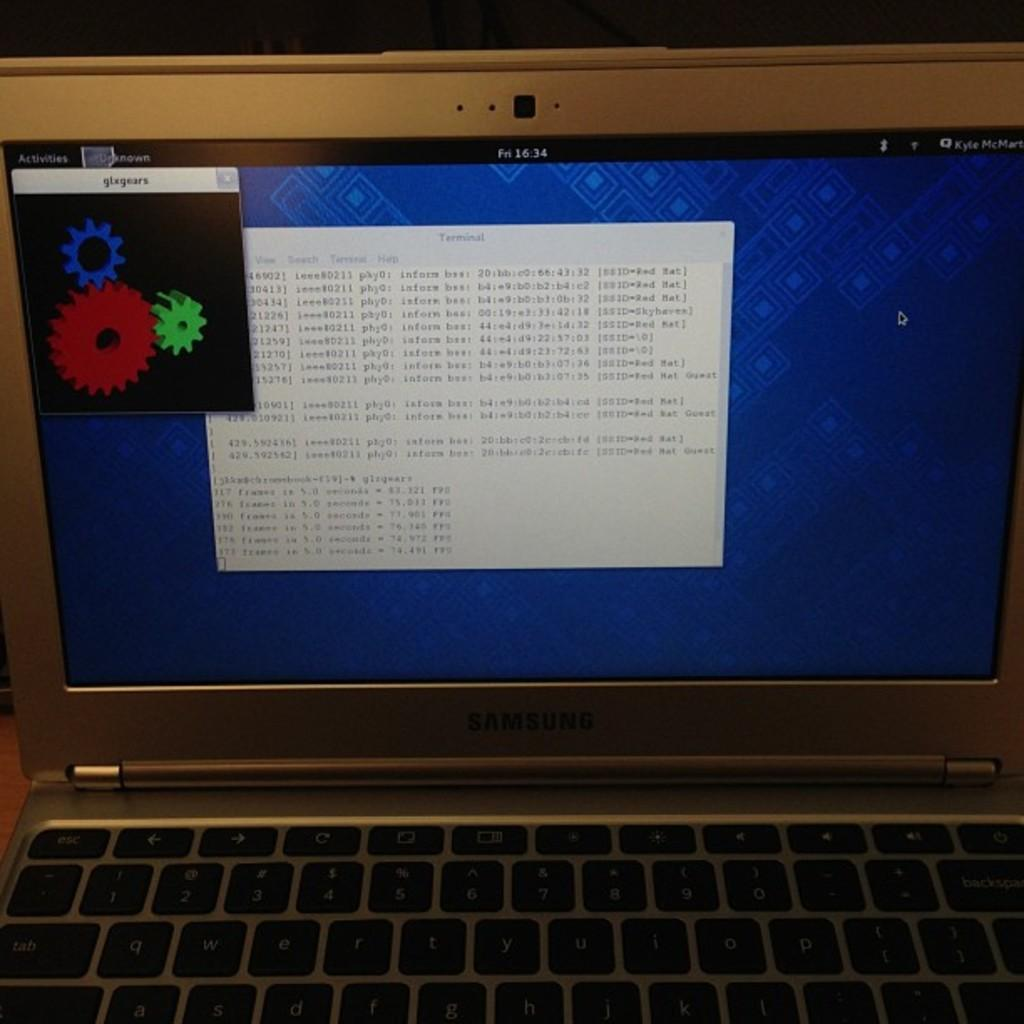<image>
Give a short and clear explanation of the subsequent image. a computer monitor with a window open reading GLX Gears 